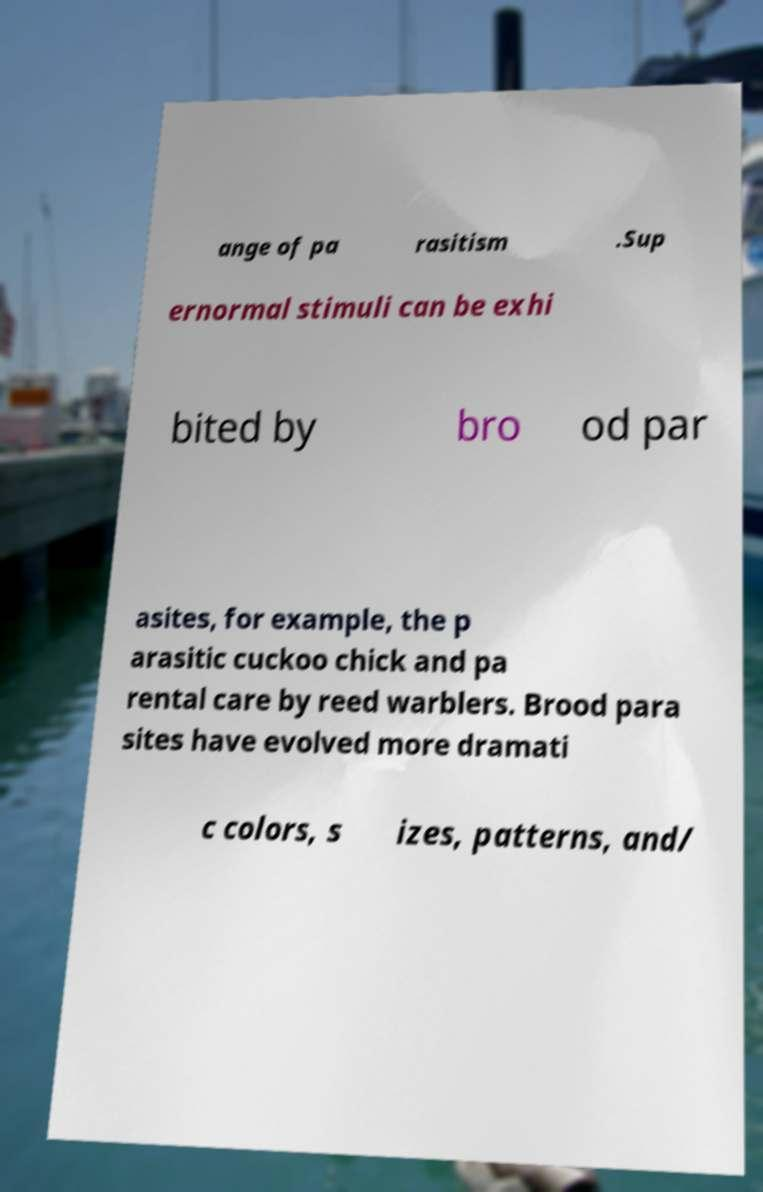Could you assist in decoding the text presented in this image and type it out clearly? ange of pa rasitism .Sup ernormal stimuli can be exhi bited by bro od par asites, for example, the p arasitic cuckoo chick and pa rental care by reed warblers. Brood para sites have evolved more dramati c colors, s izes, patterns, and/ 